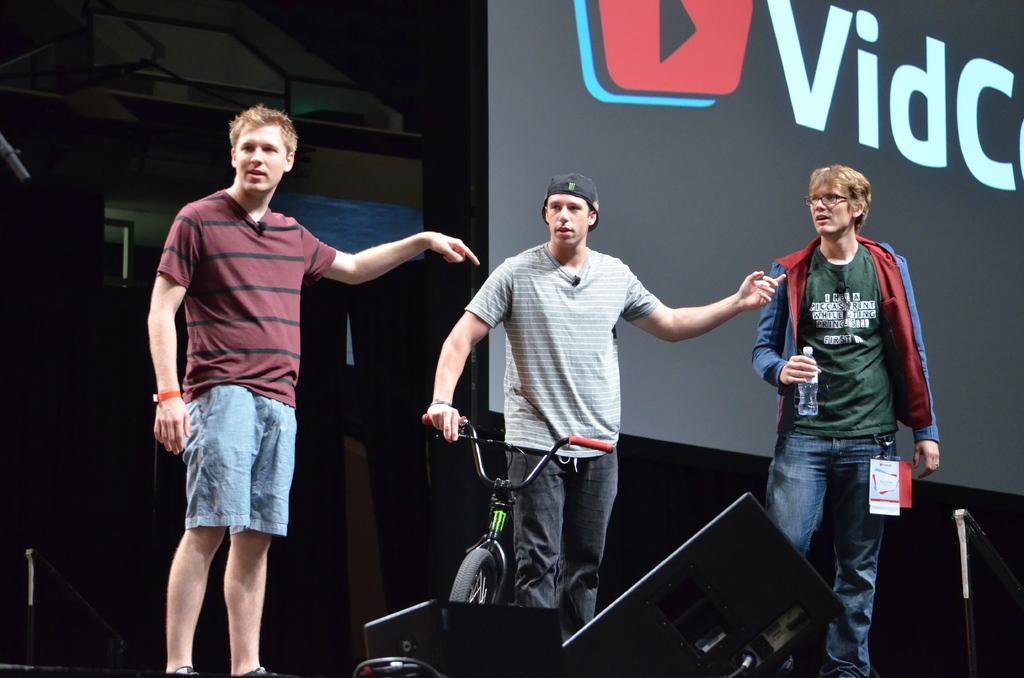Please provide a concise description of this image. In this image we can see three persons, one of them is holding a bicycle, another person is holding a bottle, there are speakers, also we can see the wall, and there is a screen with some text on it. 